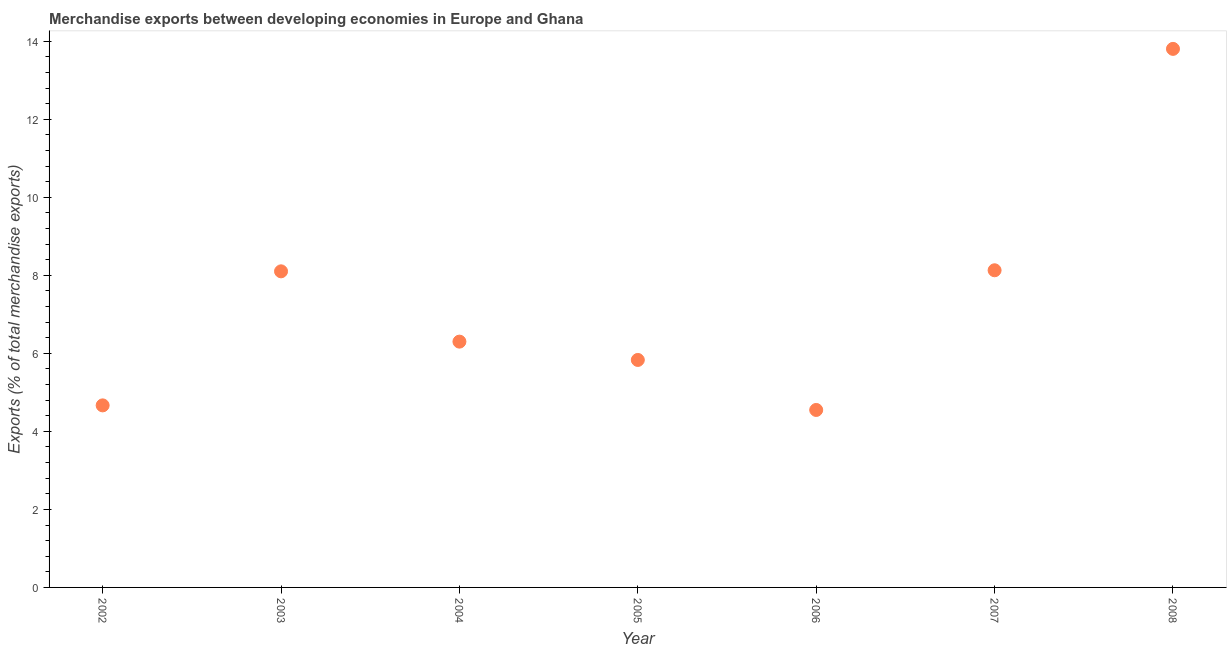What is the merchandise exports in 2004?
Give a very brief answer. 6.3. Across all years, what is the maximum merchandise exports?
Your response must be concise. 13.8. Across all years, what is the minimum merchandise exports?
Give a very brief answer. 4.55. What is the sum of the merchandise exports?
Your answer should be very brief. 51.38. What is the difference between the merchandise exports in 2003 and 2004?
Provide a short and direct response. 1.8. What is the average merchandise exports per year?
Give a very brief answer. 7.34. What is the median merchandise exports?
Offer a very short reply. 6.3. Do a majority of the years between 2008 and 2002 (inclusive) have merchandise exports greater than 4.4 %?
Offer a very short reply. Yes. What is the ratio of the merchandise exports in 2005 to that in 2007?
Ensure brevity in your answer.  0.72. What is the difference between the highest and the second highest merchandise exports?
Offer a very short reply. 5.68. What is the difference between the highest and the lowest merchandise exports?
Your answer should be compact. 9.26. In how many years, is the merchandise exports greater than the average merchandise exports taken over all years?
Offer a very short reply. 3. Does the merchandise exports monotonically increase over the years?
Provide a succinct answer. No. What is the difference between two consecutive major ticks on the Y-axis?
Your answer should be compact. 2. Does the graph contain grids?
Provide a succinct answer. No. What is the title of the graph?
Make the answer very short. Merchandise exports between developing economies in Europe and Ghana. What is the label or title of the Y-axis?
Keep it short and to the point. Exports (% of total merchandise exports). What is the Exports (% of total merchandise exports) in 2002?
Offer a terse response. 4.67. What is the Exports (% of total merchandise exports) in 2003?
Ensure brevity in your answer.  8.1. What is the Exports (% of total merchandise exports) in 2004?
Provide a succinct answer. 6.3. What is the Exports (% of total merchandise exports) in 2005?
Offer a very short reply. 5.83. What is the Exports (% of total merchandise exports) in 2006?
Your answer should be very brief. 4.55. What is the Exports (% of total merchandise exports) in 2007?
Your response must be concise. 8.13. What is the Exports (% of total merchandise exports) in 2008?
Keep it short and to the point. 13.8. What is the difference between the Exports (% of total merchandise exports) in 2002 and 2003?
Make the answer very short. -3.44. What is the difference between the Exports (% of total merchandise exports) in 2002 and 2004?
Your answer should be compact. -1.63. What is the difference between the Exports (% of total merchandise exports) in 2002 and 2005?
Your answer should be very brief. -1.16. What is the difference between the Exports (% of total merchandise exports) in 2002 and 2006?
Your response must be concise. 0.12. What is the difference between the Exports (% of total merchandise exports) in 2002 and 2007?
Keep it short and to the point. -3.46. What is the difference between the Exports (% of total merchandise exports) in 2002 and 2008?
Offer a terse response. -9.14. What is the difference between the Exports (% of total merchandise exports) in 2003 and 2004?
Your answer should be very brief. 1.8. What is the difference between the Exports (% of total merchandise exports) in 2003 and 2005?
Your response must be concise. 2.27. What is the difference between the Exports (% of total merchandise exports) in 2003 and 2006?
Give a very brief answer. 3.55. What is the difference between the Exports (% of total merchandise exports) in 2003 and 2007?
Give a very brief answer. -0.03. What is the difference between the Exports (% of total merchandise exports) in 2003 and 2008?
Give a very brief answer. -5.7. What is the difference between the Exports (% of total merchandise exports) in 2004 and 2005?
Keep it short and to the point. 0.47. What is the difference between the Exports (% of total merchandise exports) in 2004 and 2006?
Provide a short and direct response. 1.75. What is the difference between the Exports (% of total merchandise exports) in 2004 and 2007?
Provide a succinct answer. -1.83. What is the difference between the Exports (% of total merchandise exports) in 2004 and 2008?
Your answer should be compact. -7.5. What is the difference between the Exports (% of total merchandise exports) in 2005 and 2006?
Your answer should be very brief. 1.28. What is the difference between the Exports (% of total merchandise exports) in 2005 and 2007?
Make the answer very short. -2.3. What is the difference between the Exports (% of total merchandise exports) in 2005 and 2008?
Keep it short and to the point. -7.97. What is the difference between the Exports (% of total merchandise exports) in 2006 and 2007?
Offer a very short reply. -3.58. What is the difference between the Exports (% of total merchandise exports) in 2006 and 2008?
Offer a very short reply. -9.26. What is the difference between the Exports (% of total merchandise exports) in 2007 and 2008?
Make the answer very short. -5.68. What is the ratio of the Exports (% of total merchandise exports) in 2002 to that in 2003?
Provide a short and direct response. 0.58. What is the ratio of the Exports (% of total merchandise exports) in 2002 to that in 2004?
Offer a terse response. 0.74. What is the ratio of the Exports (% of total merchandise exports) in 2002 to that in 2006?
Give a very brief answer. 1.03. What is the ratio of the Exports (% of total merchandise exports) in 2002 to that in 2007?
Provide a succinct answer. 0.57. What is the ratio of the Exports (% of total merchandise exports) in 2002 to that in 2008?
Your response must be concise. 0.34. What is the ratio of the Exports (% of total merchandise exports) in 2003 to that in 2004?
Offer a terse response. 1.29. What is the ratio of the Exports (% of total merchandise exports) in 2003 to that in 2005?
Ensure brevity in your answer.  1.39. What is the ratio of the Exports (% of total merchandise exports) in 2003 to that in 2006?
Your answer should be compact. 1.78. What is the ratio of the Exports (% of total merchandise exports) in 2003 to that in 2007?
Your response must be concise. 1. What is the ratio of the Exports (% of total merchandise exports) in 2003 to that in 2008?
Offer a terse response. 0.59. What is the ratio of the Exports (% of total merchandise exports) in 2004 to that in 2006?
Provide a short and direct response. 1.39. What is the ratio of the Exports (% of total merchandise exports) in 2004 to that in 2007?
Keep it short and to the point. 0.78. What is the ratio of the Exports (% of total merchandise exports) in 2004 to that in 2008?
Offer a terse response. 0.46. What is the ratio of the Exports (% of total merchandise exports) in 2005 to that in 2006?
Ensure brevity in your answer.  1.28. What is the ratio of the Exports (% of total merchandise exports) in 2005 to that in 2007?
Give a very brief answer. 0.72. What is the ratio of the Exports (% of total merchandise exports) in 2005 to that in 2008?
Your answer should be very brief. 0.42. What is the ratio of the Exports (% of total merchandise exports) in 2006 to that in 2007?
Your answer should be compact. 0.56. What is the ratio of the Exports (% of total merchandise exports) in 2006 to that in 2008?
Your answer should be compact. 0.33. What is the ratio of the Exports (% of total merchandise exports) in 2007 to that in 2008?
Ensure brevity in your answer.  0.59. 